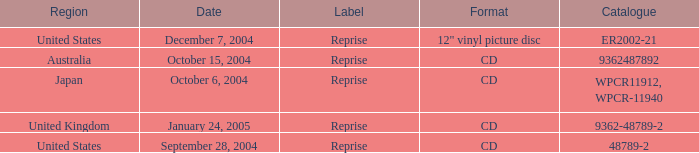Can you provide information about the catalog from october 15, 2004? 9362487892.0. 